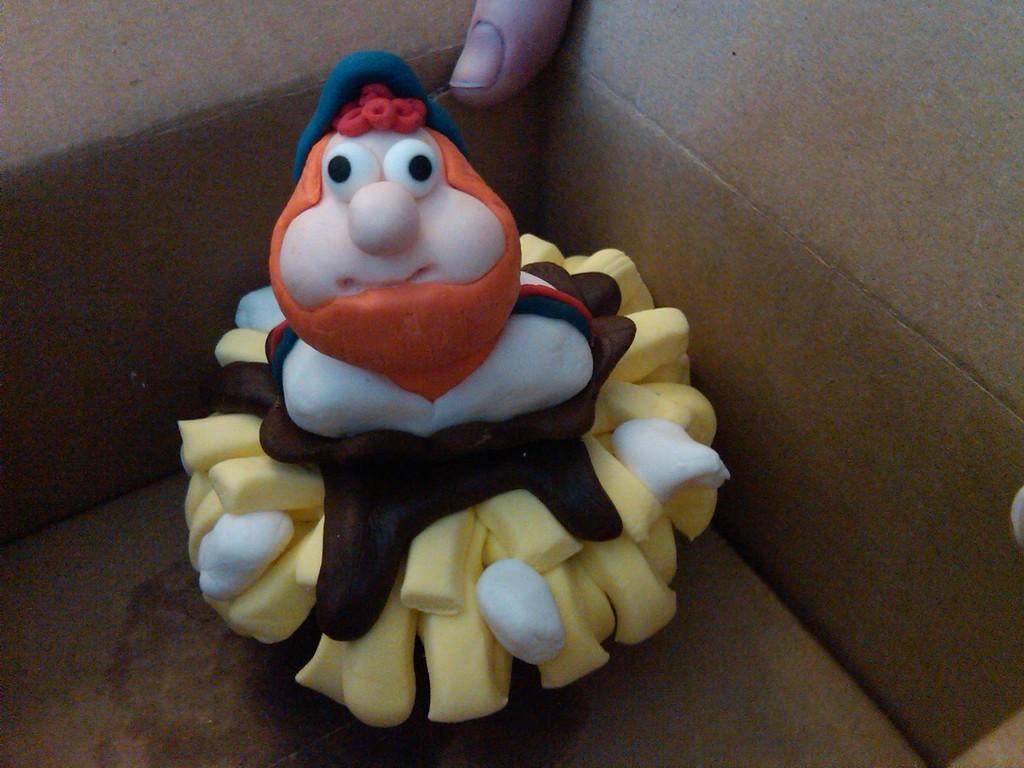In one or two sentences, can you explain what this image depicts? This is a zoomed in picture. In the foreground we can see the toy of a person seems to be placed in a box. In the background we can see the thumb of a person. 